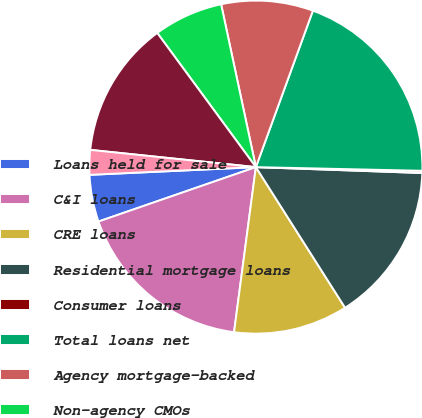Convert chart to OTSL. <chart><loc_0><loc_0><loc_500><loc_500><pie_chart><fcel>Loans held for sale<fcel>C&I loans<fcel>CRE loans<fcel>Residential mortgage loans<fcel>Consumer loans<fcel>Total loans net<fcel>Agency mortgage-backed<fcel>Non-agency CMOs<fcel>Money market funds cash and<fcel>FHLB stock Federal Reserve<nl><fcel>4.56%<fcel>17.61%<fcel>11.09%<fcel>15.44%<fcel>0.21%<fcel>19.79%<fcel>8.91%<fcel>6.74%<fcel>13.26%<fcel>2.39%<nl></chart> 